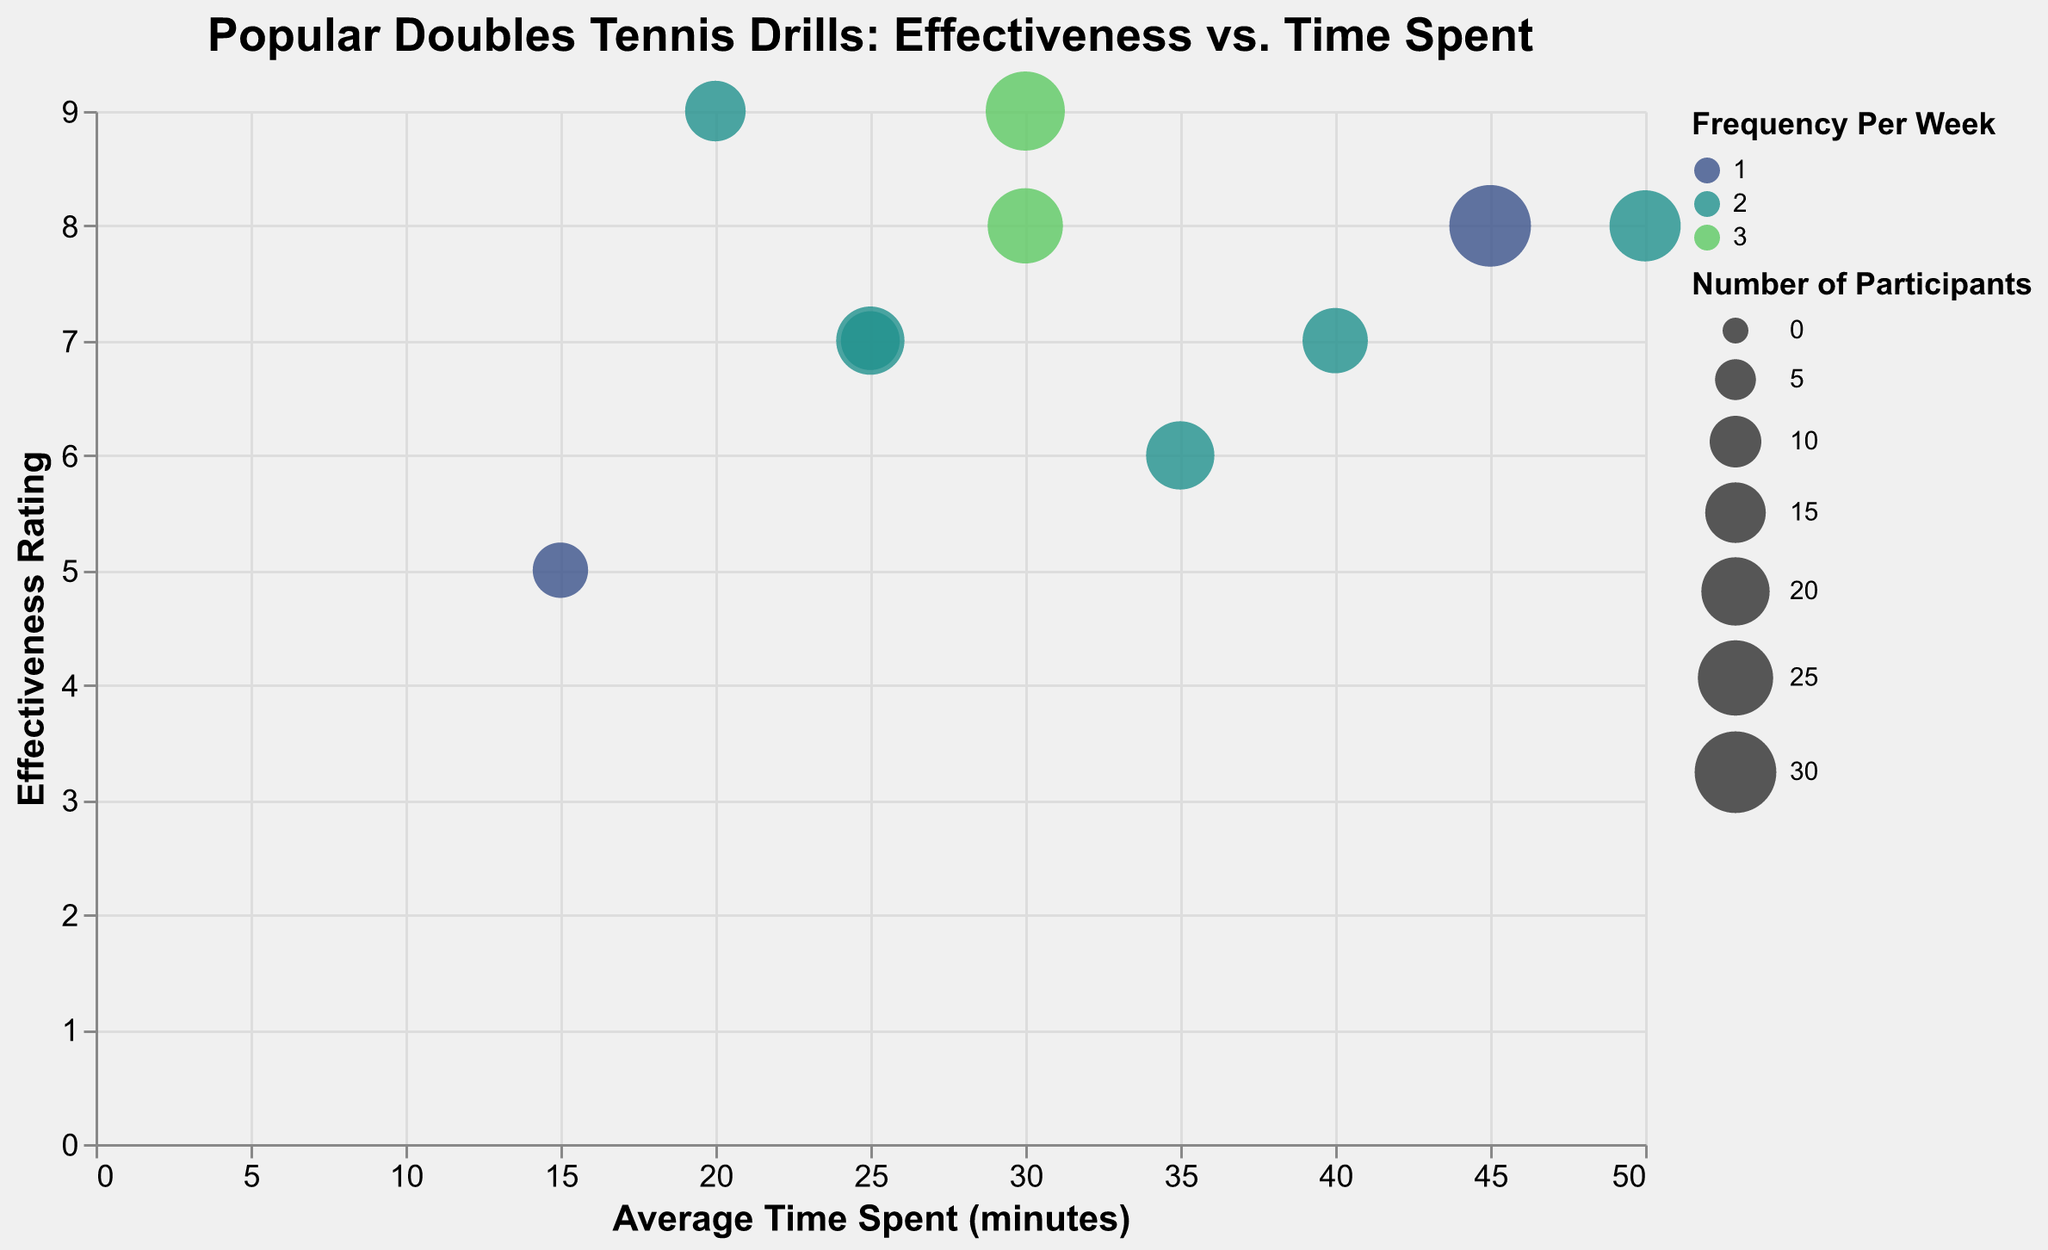What is the title of the plot? The title is usually written on top of the plot. In this case, it reads "Popular Doubles Tennis Drills: Effectiveness vs. Time Spent".
Answer: Popular Doubles Tennis Drills: Effectiveness vs. Time Spent How many drills are included in the chart? To find this, count the number of distinct bubbles in the chart. Each bubble represents a different drill.
Answer: 10 Which drill has the highest effectiveness rating? Look for the bubble with the highest y-axis value. The y-axis represents the "Effectiveness Rating".
Answer: Poaching Drills and Serve and Volley (Effectiveness Rating of 9) Which drill takes the most time on average to perform per week? Identify the bubble that is furthest right on the x-axis since it represents the "Average Time Spent (minutes)".
Answer: Crosscourt Rally (50 minutes) Which drill is practiced the least frequently per week? Find the color code that represents the lowest frequency per week and identify the corresponding drill.
Answer: Shadow Drills and King of the Court (1 time per week) How many participants reported on the Volley Exchange drill? Hovering over or looking at the bubble’s tooltip for “Volley Exchange” gives the "Number of Participants".
Answer: 25 Among the drills rated as 7 for effectiveness, which one has the highest average time spent? Look for bubbles with y-axis value of 7, then compare their x-axis values.
Answer: Two-on-One Baseline (40 minutes) What is the effectiveness rating for drills that have 3 frequency per week? Identify bubbles with colors representing frequency 3, then read their y-axis values.
Answer: 8 and 9 (Volley Exchange and Serve and Volley) Which drill has the lowest number of participants and what is its effectiveness rating? Identify the smallest bubble on the chart and check its y-axis value.
Answer: Shadow Drills (Effectiveness Rating of 5) 